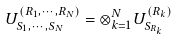<formula> <loc_0><loc_0><loc_500><loc_500>U _ { S _ { 1 } , \cdots , S _ { N } } ^ { \left ( R _ { 1 } , \cdots , R _ { N } \right ) } = \otimes _ { k = 1 } ^ { N } U _ { S _ { R _ { k } } } ^ { \left ( R _ { k } \right ) }</formula> 